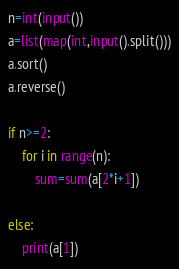Convert code to text. <code><loc_0><loc_0><loc_500><loc_500><_Python_>n=int(input())
a=list(map(int,input().split()))
a.sort()
a.reverse()

if n>=2:
    for i in range(n):
        sum=sum(a[2*i+1])
    
else:
    print(a[1])
</code> 